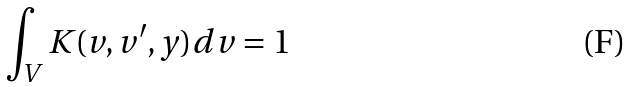<formula> <loc_0><loc_0><loc_500><loc_500>\int _ { V } K ( v , v ^ { \prime } , y ) d v = 1</formula> 